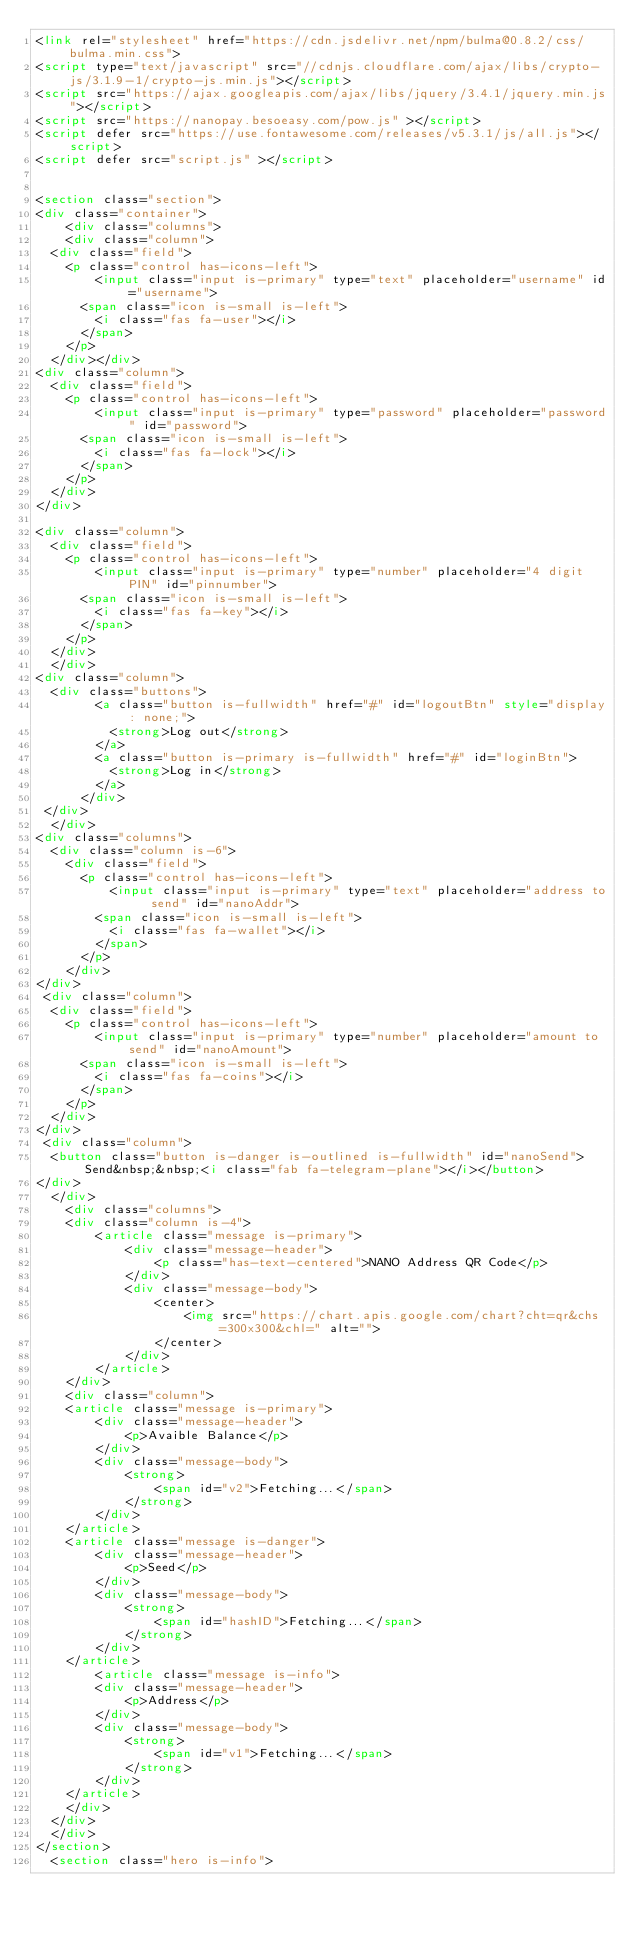Convert code to text. <code><loc_0><loc_0><loc_500><loc_500><_HTML_><link rel="stylesheet" href="https://cdn.jsdelivr.net/npm/bulma@0.8.2/css/bulma.min.css">
<script type="text/javascript" src="//cdnjs.cloudflare.com/ajax/libs/crypto-js/3.1.9-1/crypto-js.min.js"></script>
<script src="https://ajax.googleapis.com/ajax/libs/jquery/3.4.1/jquery.min.js"></script>
<script src="https://nanopay.besoeasy.com/pow.js" ></script>
<script defer src="https://use.fontawesome.com/releases/v5.3.1/js/all.js"></script>
<script defer src="script.js" ></script>


<section class="section">
<div class="container">
    <div class="columns">
    <div class="column">
  <div class="field">
    <p class="control has-icons-left">
        <input class="input is-primary" type="text" placeholder="username" id="username">
      <span class="icon is-small is-left">
        <i class="fas fa-user"></i>
      </span>
    </p>
  </div></div>
<div class="column">
  <div class="field">
    <p class="control has-icons-left">
        <input class="input is-primary" type="password" placeholder="password" id="password">
      <span class="icon is-small is-left">
        <i class="fas fa-lock"></i>
      </span>
    </p>
  </div>
</div>
        
<div class="column">
  <div class="field">
    <p class="control has-icons-left">
        <input class="input is-primary" type="number" placeholder="4 digit PIN" id="pinnumber">
      <span class="icon is-small is-left">
        <i class="fas fa-key"></i>
      </span>
    </p>
  </div>
  </div>
<div class="column">
  <div class="buttons">
        <a class="button is-fullwidth" href="#" id="logoutBtn" style="display: none;">    
          <strong>Log out</strong>
        </a>
        <a class="button is-primary is-fullwidth" href="#" id="loginBtn">    
          <strong>Log in</strong>
        </a>
      </div>
 </div>
  </div>
<div class="columns">
  <div class="column is-6">
    <div class="field">
      <p class="control has-icons-left">
          <input class="input is-primary" type="text" placeholder="address to send" id="nanoAddr">
        <span class="icon is-small is-left">
          <i class="fas fa-wallet"></i>
        </span>
      </p>
    </div>
</div>
 <div class="column">
  <div class="field">
    <p class="control has-icons-left">
        <input class="input is-primary" type="number" placeholder="amount to send" id="nanoAmount">
      <span class="icon is-small is-left">
        <i class="fas fa-coins"></i>
      </span>
    </p>
  </div>
</div>   
 <div class="column">
  <button class="button is-danger is-outlined is-fullwidth" id="nanoSend">Send&nbsp;&nbsp;<i class="fab fa-telegram-plane"></i></button>
</div>
  </div>
    <div class="columns">
    <div class="column is-4">
        <article class="message is-primary">
            <div class="message-header">
                <p class="has-text-centered">NANO Address QR Code</p>
            </div>
            <div class="message-body">
                <center>
                    <img src="https://chart.apis.google.com/chart?cht=qr&chs=300x300&chl=" alt="">
                </center>
            </div>
        </article>
    </div>
    <div class="column">
    <article class="message is-primary">
        <div class="message-header">
            <p>Avaible Balance</p>
        </div>
        <div class="message-body">
            <strong>
                <span id="v2">Fetching...</span>
            </strong>
        </div>
    </article>
    <article class="message is-danger">
        <div class="message-header">
            <p>Seed</p>
        </div>
        <div class="message-body">
            <strong>
                <span id="hashID">Fetching...</span>
            </strong>
        </div>
    </article>
        <article class="message is-info">
        <div class="message-header">
            <p>Address</p>
        </div>
        <div class="message-body">
            <strong>        
                <span id="v1">Fetching...</span>
            </strong>
        </div>
    </article>
    </div>
  </div>
  </div>
</section>
  <section class="hero is-info"></code> 